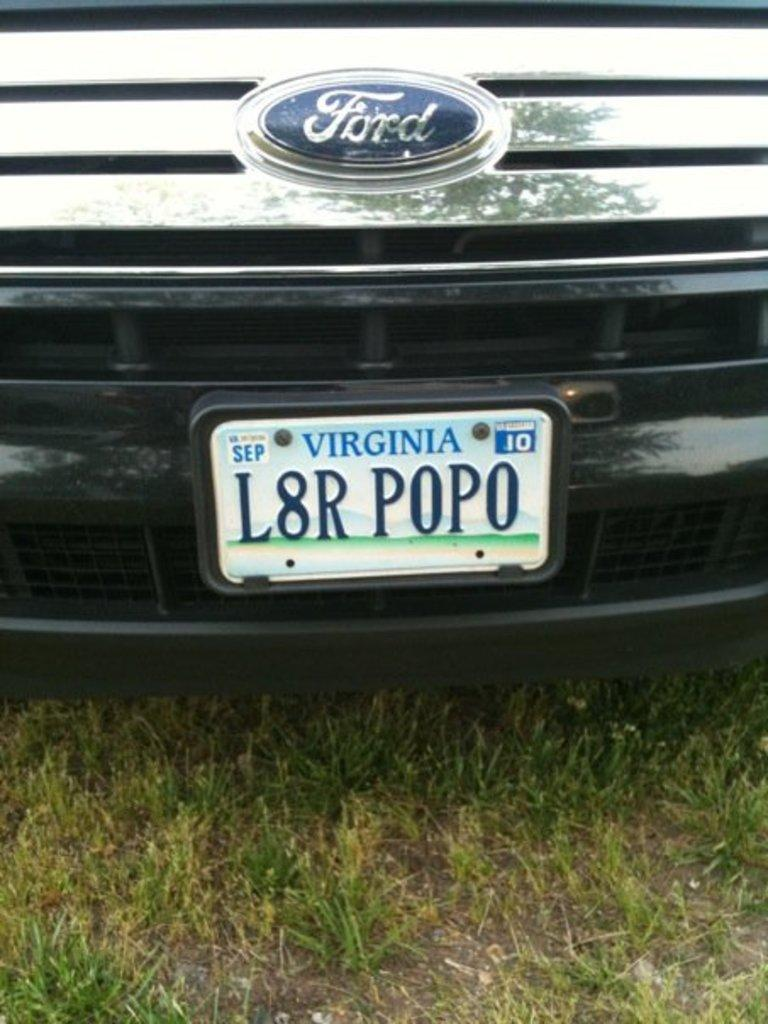<image>
Render a clear and concise summary of the photo. An up close photo of a Ford truck with a Virginia plate attached to the front. 